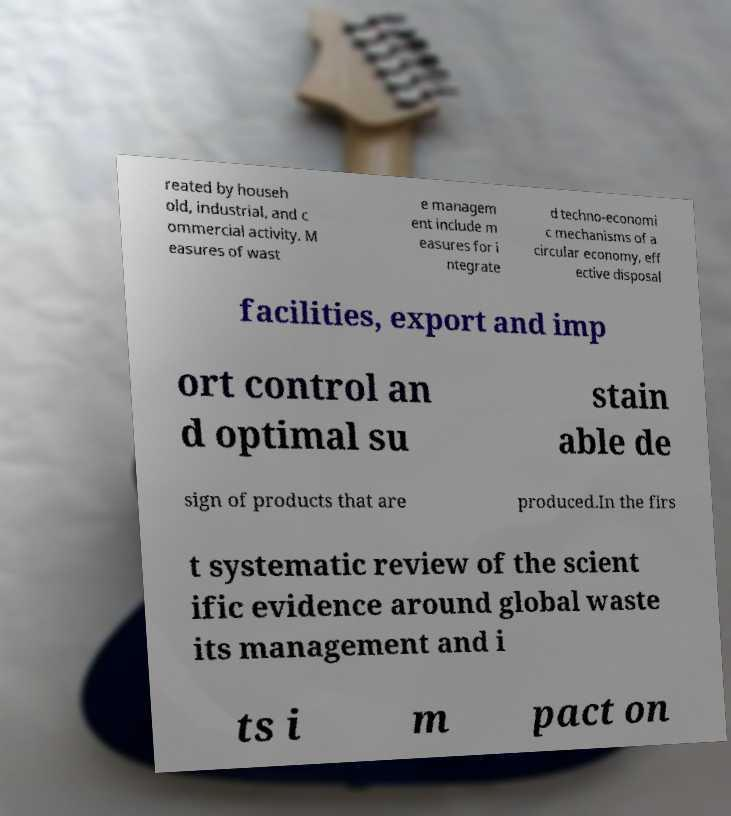There's text embedded in this image that I need extracted. Can you transcribe it verbatim? reated by househ old, industrial, and c ommercial activity. M easures of wast e managem ent include m easures for i ntegrate d techno-economi c mechanisms of a circular economy, eff ective disposal facilities, export and imp ort control an d optimal su stain able de sign of products that are produced.In the firs t systematic review of the scient ific evidence around global waste its management and i ts i m pact on 